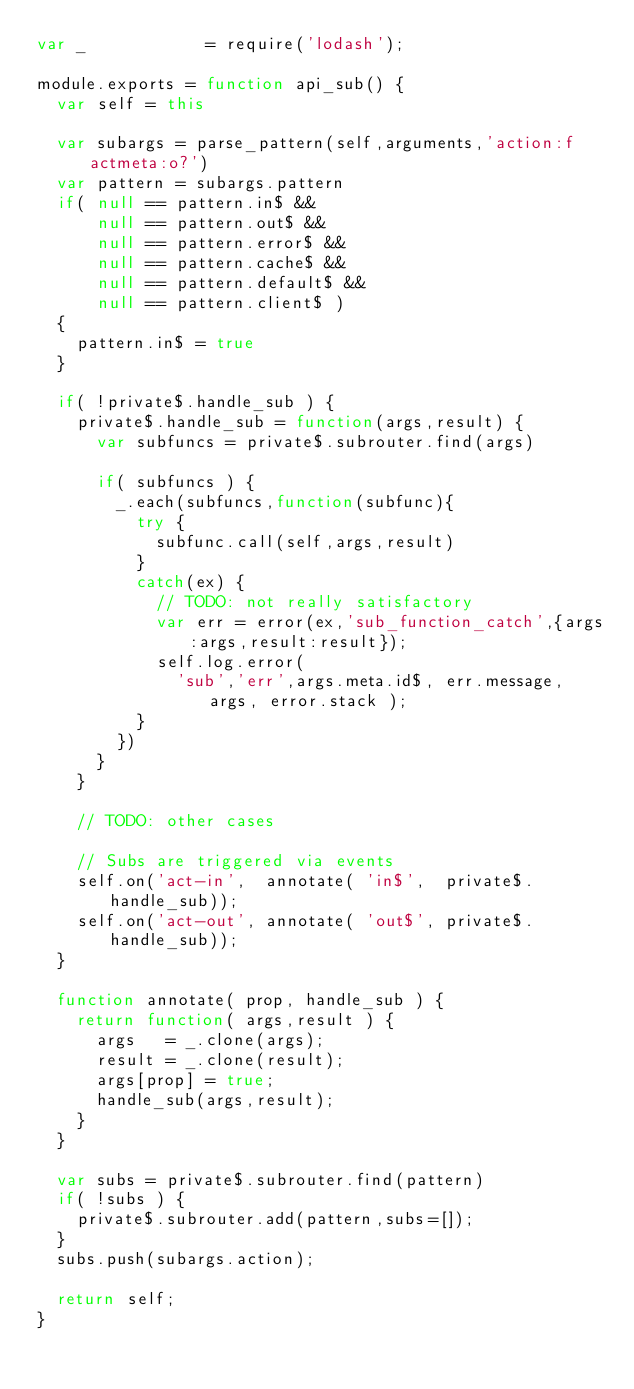<code> <loc_0><loc_0><loc_500><loc_500><_JavaScript_>var _            = require('lodash');

module.exports = function api_sub() {
  var self = this

  var subargs = parse_pattern(self,arguments,'action:f actmeta:o?')
  var pattern = subargs.pattern
  if( null == pattern.in$ &&
      null == pattern.out$ &&
      null == pattern.error$ &&
      null == pattern.cache$ &&
      null == pattern.default$ &&
      null == pattern.client$ )
  {
    pattern.in$ = true
  }

  if( !private$.handle_sub ) {
    private$.handle_sub = function(args,result) {
      var subfuncs = private$.subrouter.find(args)

      if( subfuncs ) {
        _.each(subfuncs,function(subfunc){
          try {
            subfunc.call(self,args,result)
          }
          catch(ex) {
            // TODO: not really satisfactory
            var err = error(ex,'sub_function_catch',{args:args,result:result});
            self.log.error(
              'sub','err',args.meta.id$, err.message, args, error.stack );
          }
        })
      }
    }

    // TODO: other cases

    // Subs are triggered via events
    self.on('act-in',  annotate( 'in$',  private$.handle_sub));
    self.on('act-out', annotate( 'out$', private$.handle_sub));
  }

  function annotate( prop, handle_sub ) {
    return function( args,result ) {
      args   = _.clone(args);
      result = _.clone(result);
      args[prop] = true;
      handle_sub(args,result);
    }
  }

  var subs = private$.subrouter.find(pattern)
  if( !subs ) {
    private$.subrouter.add(pattern,subs=[]);
  }
  subs.push(subargs.action);

  return self;
}
</code> 